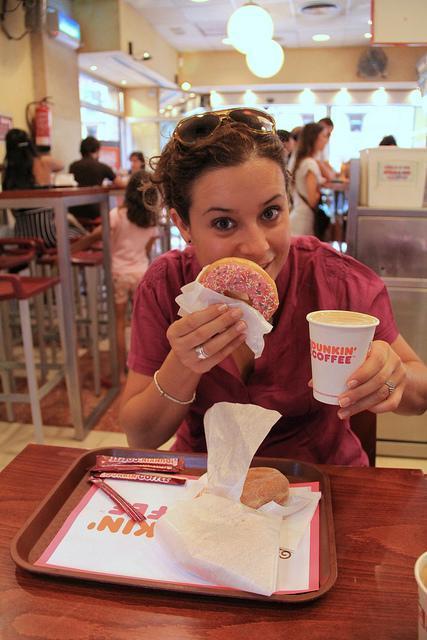How many dining tables can be seen?
Give a very brief answer. 2. How many people are visible?
Give a very brief answer. 4. 